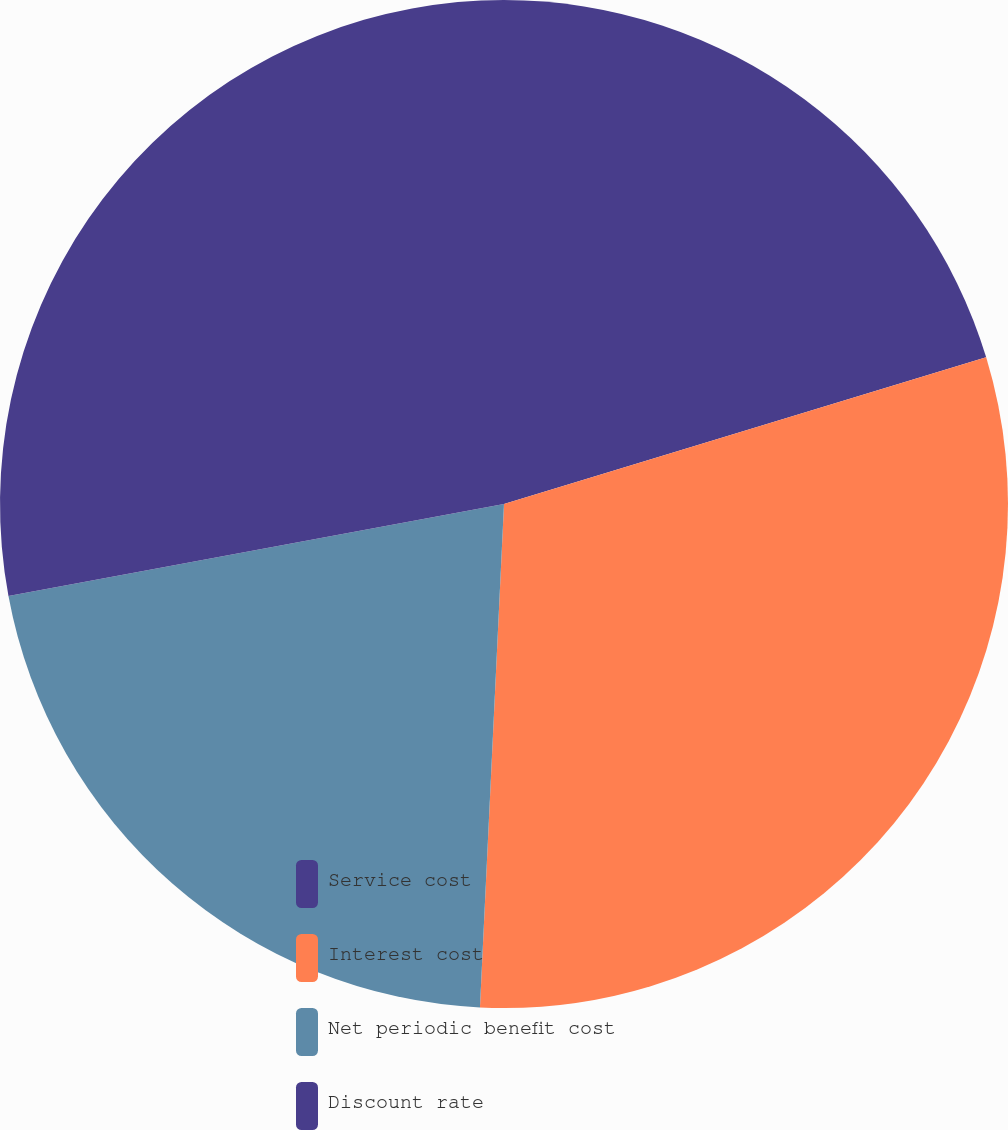Convert chart. <chart><loc_0><loc_0><loc_500><loc_500><pie_chart><fcel>Service cost<fcel>Interest cost<fcel>Net periodic benefit cost<fcel>Discount rate<nl><fcel>20.3%<fcel>30.46%<fcel>21.32%<fcel>27.92%<nl></chart> 